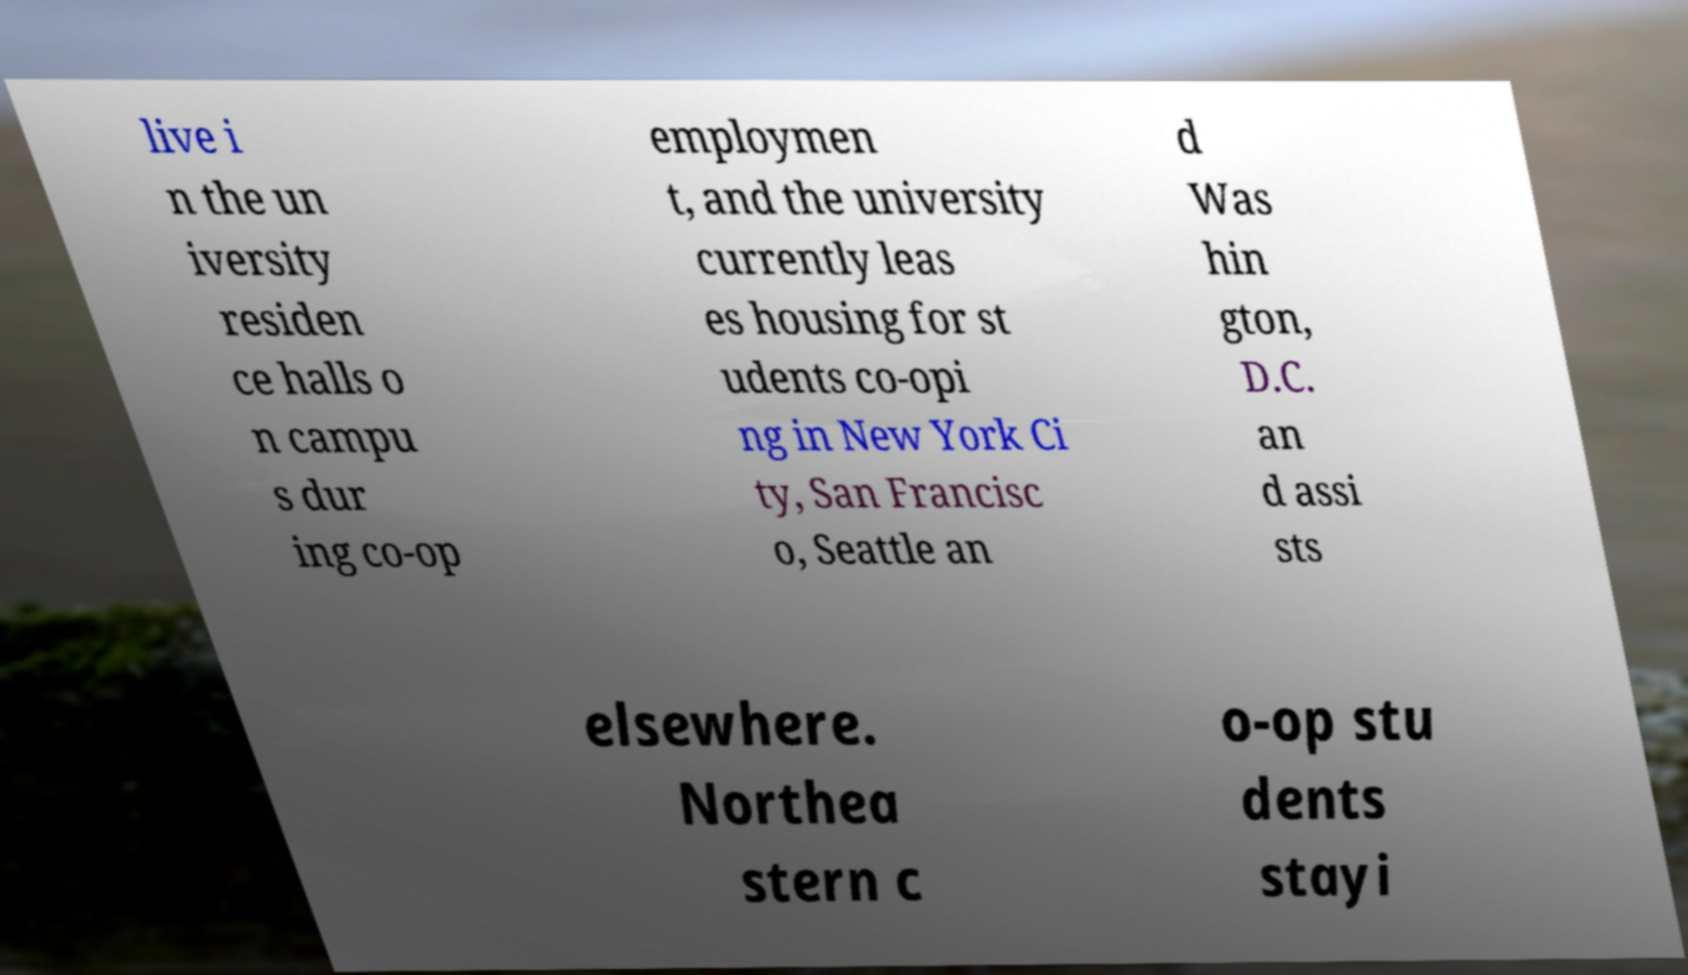For documentation purposes, I need the text within this image transcribed. Could you provide that? live i n the un iversity residen ce halls o n campu s dur ing co-op employmen t, and the university currently leas es housing for st udents co-opi ng in New York Ci ty, San Francisc o, Seattle an d Was hin gton, D.C. an d assi sts elsewhere. Northea stern c o-op stu dents stayi 